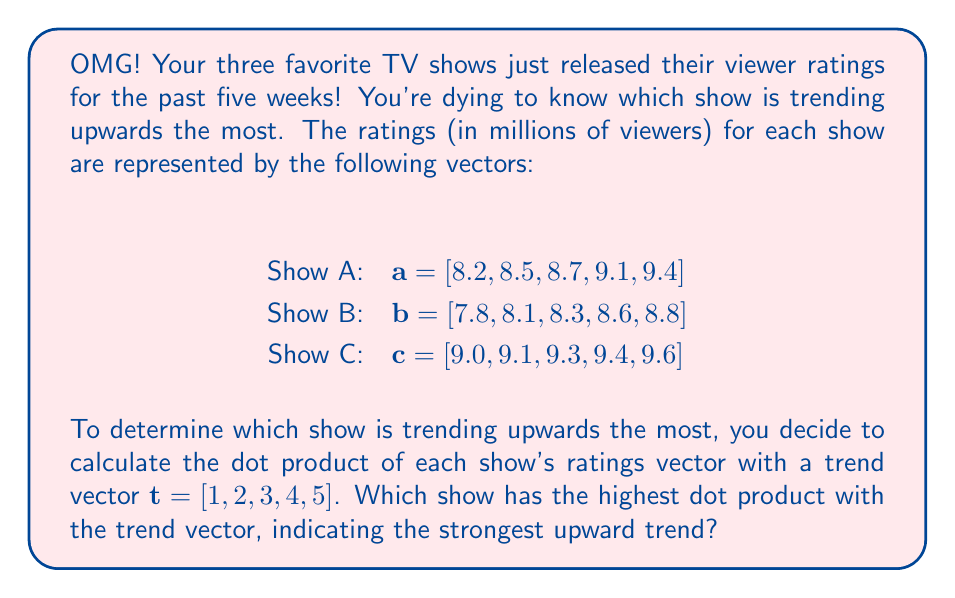Give your solution to this math problem. Let's break this down step-by-step:

1) First, we need to calculate the dot product of each show's ratings vector with the trend vector $\mathbf{t}$. The dot product is calculated by multiplying corresponding elements and then summing the results.

2) For Show A:
   $\mathbf{a} \cdot \mathbf{t} = (8.2 \times 1) + (8.5 \times 2) + (8.7 \times 3) + (9.1 \times 4) + (9.4 \times 5)$
   $= 8.2 + 17.0 + 26.1 + 36.4 + 47.0 = 134.7$

3) For Show B:
   $\mathbf{b} \cdot \mathbf{t} = (7.8 \times 1) + (8.1 \times 2) + (8.3 \times 3) + (8.6 \times 4) + (8.8 \times 5)$
   $= 7.8 + 16.2 + 24.9 + 34.4 + 44.0 = 127.3$

4) For Show C:
   $\mathbf{c} \cdot \mathbf{t} = (9.0 \times 1) + (9.1 \times 2) + (9.3 \times 3) + (9.4 \times 4) + (9.6 \times 5)$
   $= 9.0 + 18.2 + 27.9 + 37.6 + 48.0 = 140.7$

5) Now, we compare the results:
   Show A: 134.7
   Show B: 127.3
   Show C: 140.7

6) The highest dot product is for Show C, indicating that it has the strongest upward trend.
Answer: Show C has the highest dot product with the trend vector (140.7), indicating it has the strongest upward trend in viewership. 